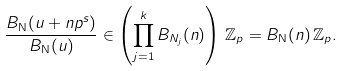<formula> <loc_0><loc_0><loc_500><loc_500>\frac { B _ { \mathbf N } ( u + n p ^ { s } ) } { B _ { \mathbf N } ( u ) } \in \left ( \prod _ { j = 1 } ^ { k } B _ { N _ { j } } ( n ) \right ) \, \mathbb { Z } _ { p } = B _ { \mathbf N } ( n ) \, \mathbb { Z } _ { p } .</formula> 